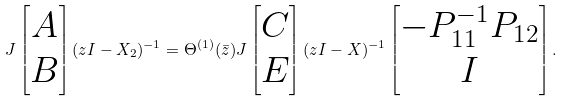Convert formula to latex. <formula><loc_0><loc_0><loc_500><loc_500>J \begin{bmatrix} A \\ B \end{bmatrix} ( z I - X _ { 2 } ) ^ { - 1 } = \Theta ^ { ( 1 ) } ( \bar { z } ) J \begin{bmatrix} C \\ E \end{bmatrix} ( z I - X ) ^ { - 1 } \begin{bmatrix} - P _ { 1 1 } ^ { - 1 } P _ { 1 2 } \\ I \end{bmatrix} .</formula> 